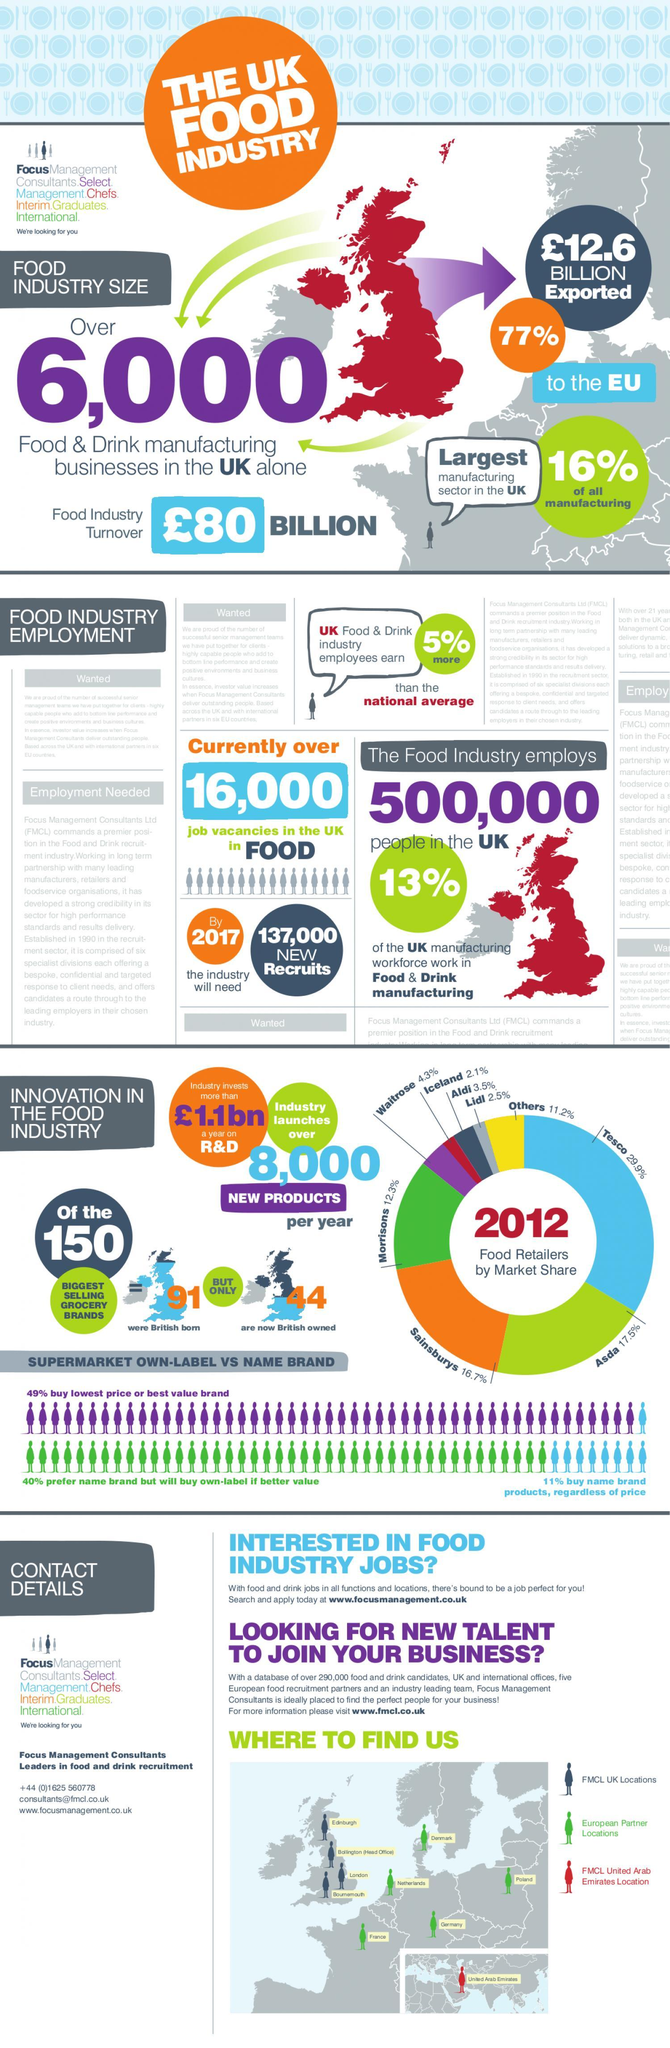How many best selling grocery brands out of 150 were British born?
Answer the question with a short phrase. 91 What is the market share of Sainsbury's in UK in 2012? 16.7% What is the market share of Morrisons in UK in 2012? 12.3% What percentage of exports were made to EU by the food industry in UK? 77% How many best selling grocery brands out of 150 are now owned by British? 44 How many new recruits are needed by the Food & Drink manufacturing industry by 2017? 137,000 Which food retailer has the highest market share in UK in 2012? Tesco Which food retailer has the second highest market share in UK in 2012? Asda What percentage of all manufacturing is contributed by the food industry in UK? 16% 